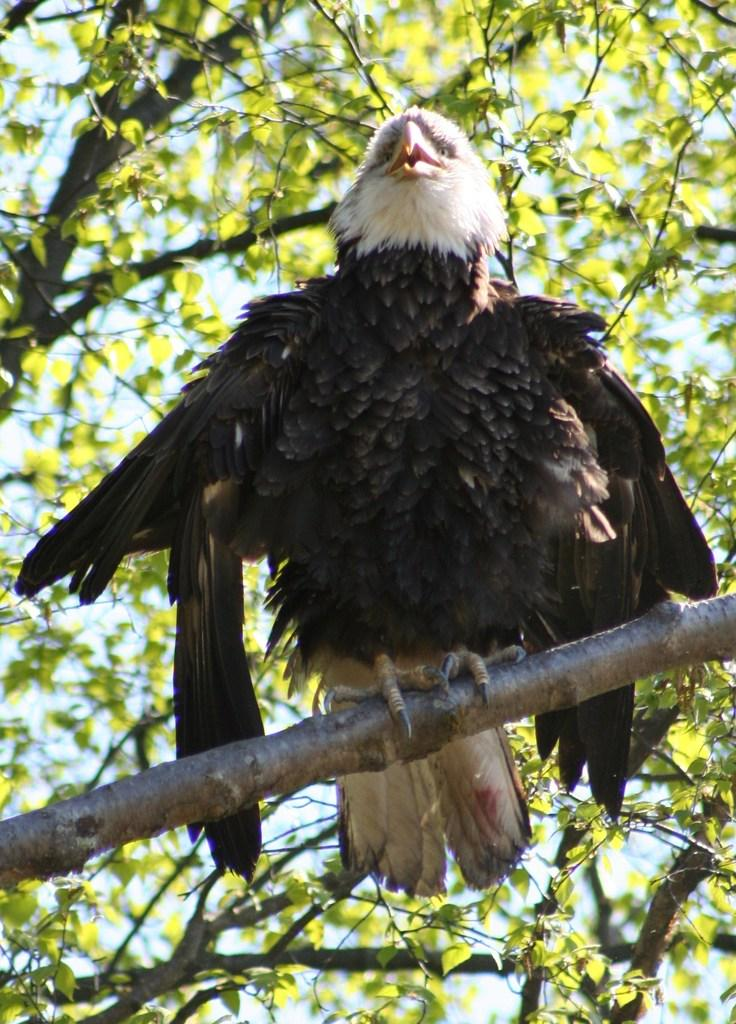What type of animal can be seen in the image? There is a bird in the image. Where is the bird located in the image? The bird is on the branch of a tree. What else is present in the image besides the bird? There is a tree in the image. What can be seen in the background of the image? The sky is visible in the background of the image. How many cows are visible in the image? There are no cows present in the image. What type of war is depicted in the image? There is no war depicted in the image; it features a bird on a tree branch. 